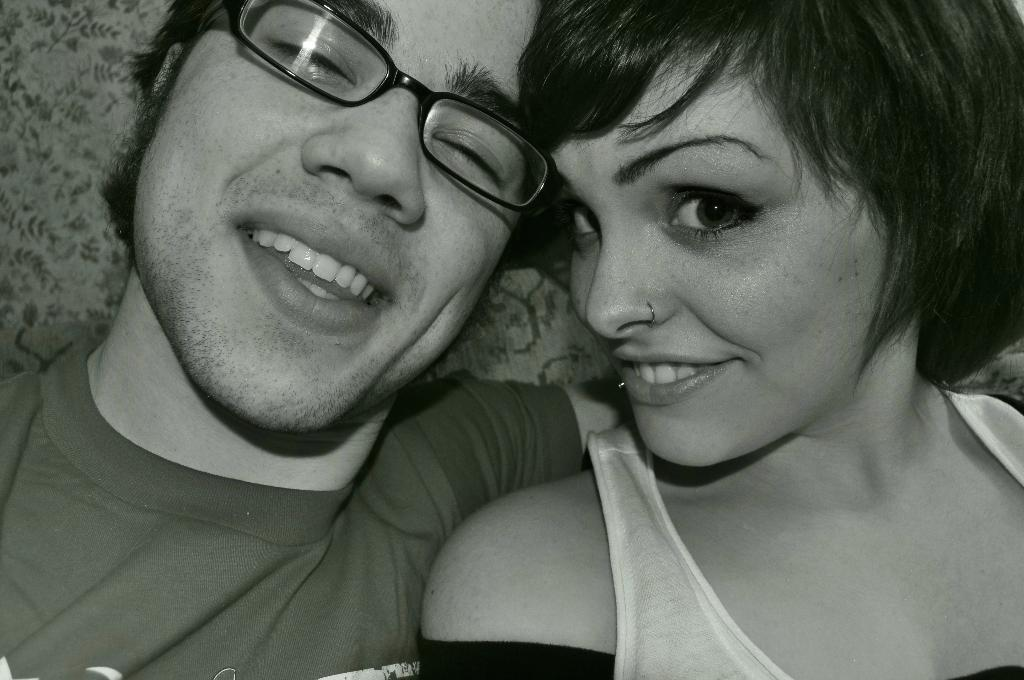How many people are present in the image? There are two people in the image, a man and a woman. What are the expressions on their faces? Both the man and the woman are smiling in the image. Can you describe the man's appearance? The man is wearing spectacles in the image. What is the color scheme of the image? The image is in black and white. What type of tail can be seen on the man in the image? There is no tail present on the man in the image. What is the smell of the library in the image? There is no library or smell mentioned in the image; it features a man and a woman smiling. 